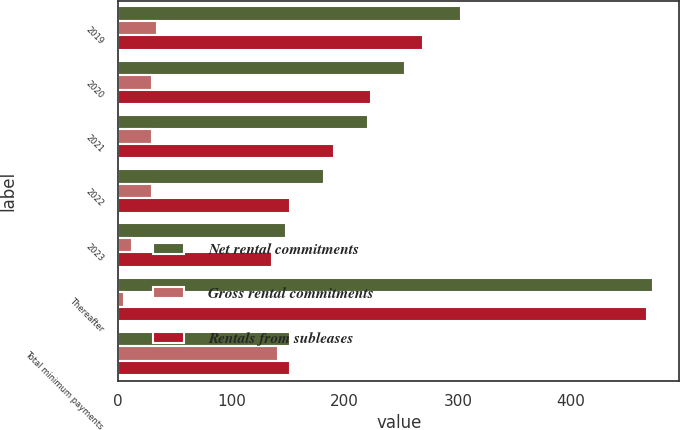Convert chart. <chart><loc_0><loc_0><loc_500><loc_500><stacked_bar_chart><ecel><fcel>2019<fcel>2020<fcel>2021<fcel>2022<fcel>2023<fcel>Thereafter<fcel>Total minimum payments<nl><fcel>Net rental commitments<fcel>303<fcel>253<fcel>221<fcel>182<fcel>148<fcel>472<fcel>152<nl><fcel>Gross rental commitments<fcel>34<fcel>30<fcel>30<fcel>30<fcel>12<fcel>5<fcel>141<nl><fcel>Rentals from subleases<fcel>269<fcel>223<fcel>191<fcel>152<fcel>136<fcel>467<fcel>152<nl></chart> 